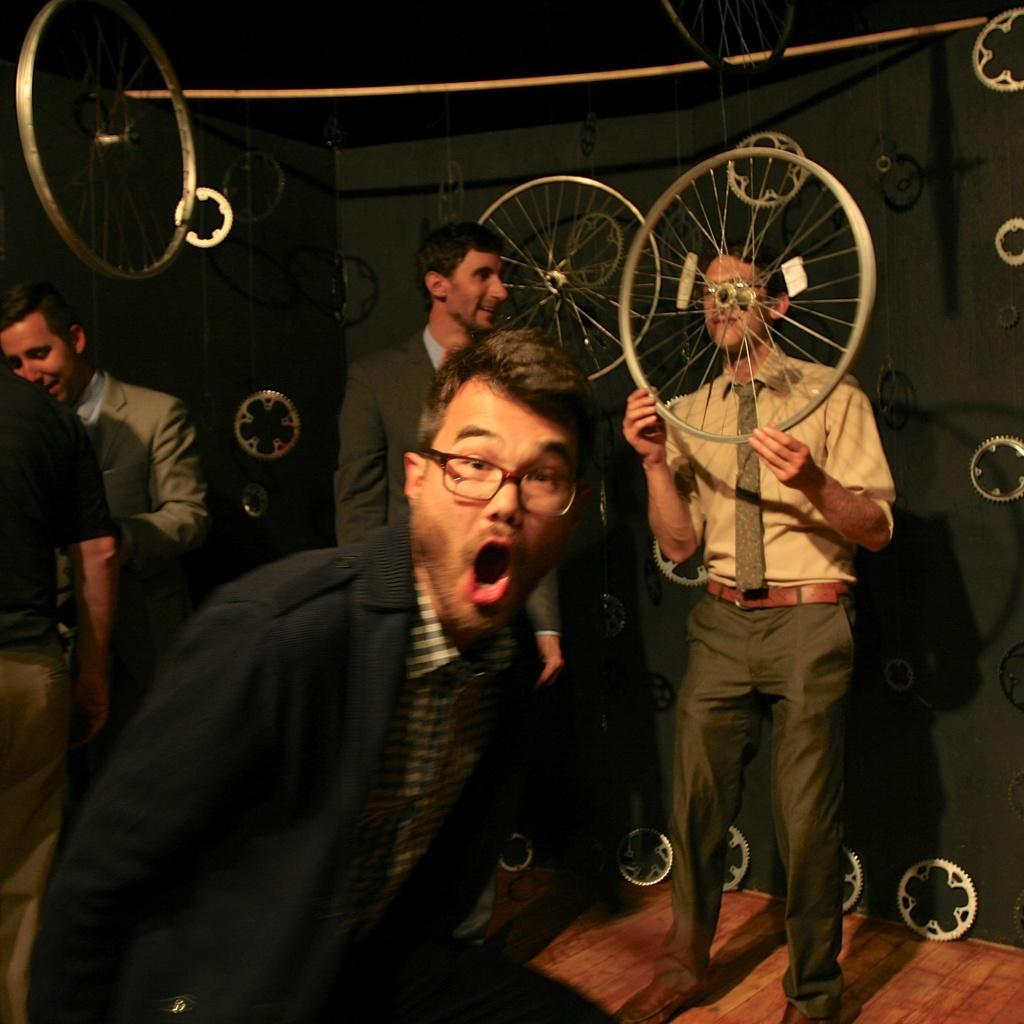In one or two sentences, can you explain what this image depicts? In this picture we can see five persons are standing, in the background there are some gears and wheels, a man on the right side is holding a wheel. 